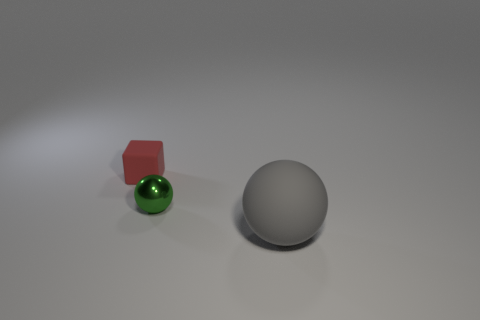Add 3 small red objects. How many objects exist? 6 Subtract all balls. How many objects are left? 1 Subtract all tiny metal things. Subtract all tiny things. How many objects are left? 0 Add 1 small red cubes. How many small red cubes are left? 2 Add 3 small shiny objects. How many small shiny objects exist? 4 Subtract 0 blue blocks. How many objects are left? 3 